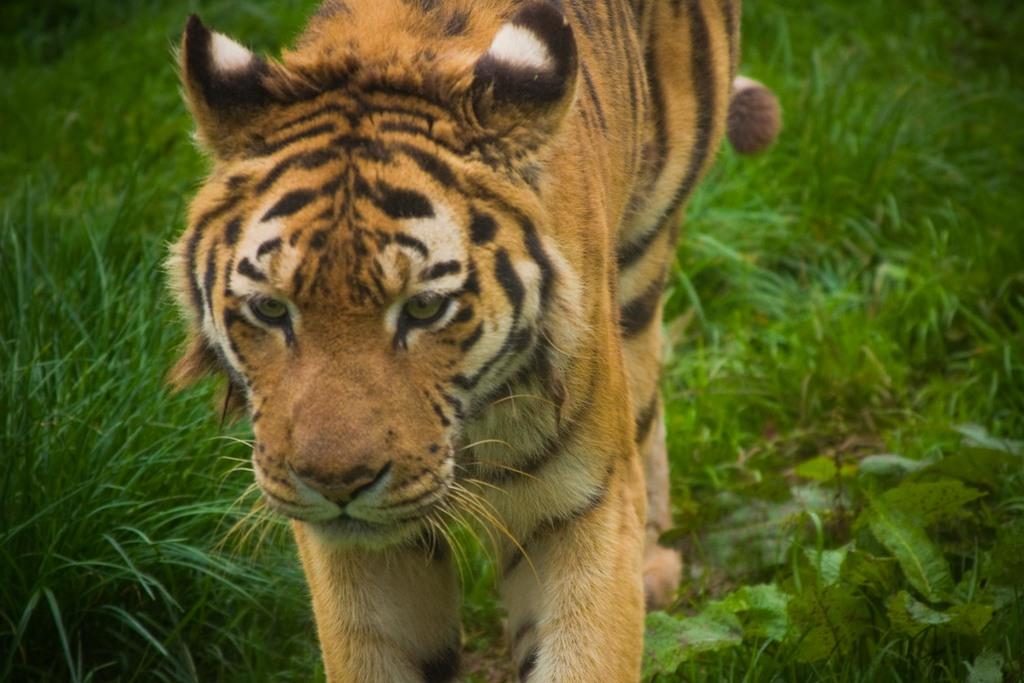What type of animal is in the image? The facts do not specify the type of animal, but it has brown and black coloring, is on the grass, and has visible whiskers. What colors can be seen on the animal in the image? The animal has brown and black coloring. Where is the animal located in the image? The animal is on the grass. What feature is visible on the animal's face? The animal has visible whiskers. What type of twig is the animal holding in its mouth in the image? There is no twig present in the image; the animal has visible whiskers, but no object is mentioned in the provided facts. 